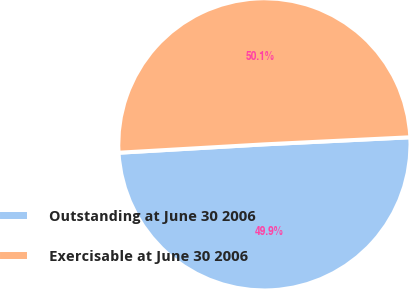Convert chart to OTSL. <chart><loc_0><loc_0><loc_500><loc_500><pie_chart><fcel>Outstanding at June 30 2006<fcel>Exercisable at June 30 2006<nl><fcel>49.86%<fcel>50.14%<nl></chart> 